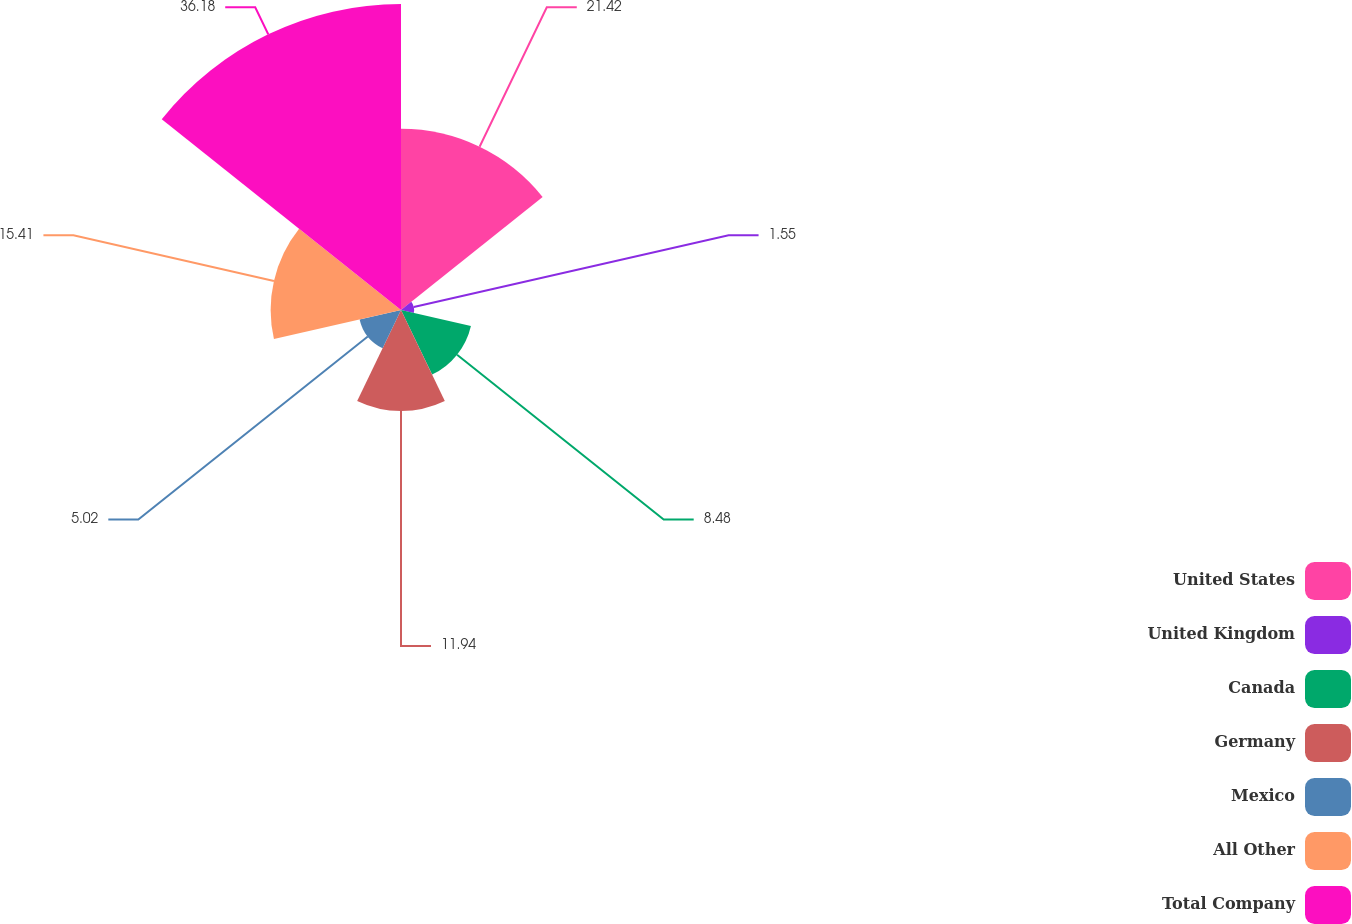Convert chart. <chart><loc_0><loc_0><loc_500><loc_500><pie_chart><fcel>United States<fcel>United Kingdom<fcel>Canada<fcel>Germany<fcel>Mexico<fcel>All Other<fcel>Total Company<nl><fcel>21.42%<fcel>1.55%<fcel>8.48%<fcel>11.94%<fcel>5.02%<fcel>15.41%<fcel>36.18%<nl></chart> 